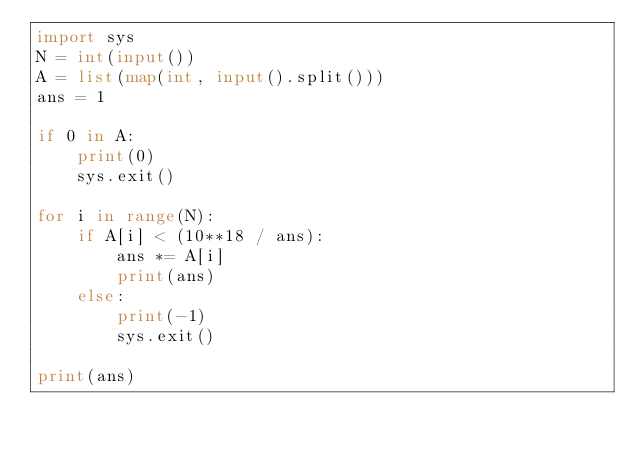Convert code to text. <code><loc_0><loc_0><loc_500><loc_500><_Python_>import sys
N = int(input())
A = list(map(int, input().split()))
ans = 1

if 0 in A:
    print(0)
    sys.exit()

for i in range(N):
    if A[i] < (10**18 / ans):
        ans *= A[i]
        print(ans)
    else:
        print(-1)
        sys.exit()

print(ans)
</code> 